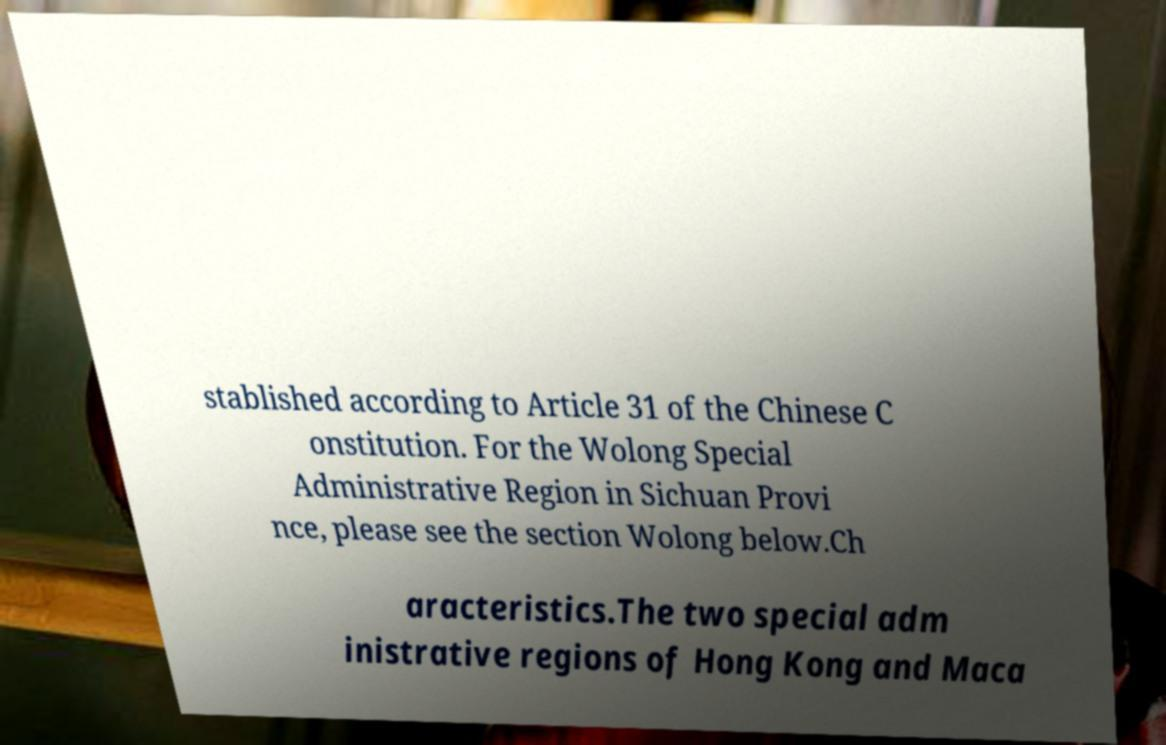Can you accurately transcribe the text from the provided image for me? stablished according to Article 31 of the Chinese C onstitution. For the Wolong Special Administrative Region in Sichuan Provi nce, please see the section Wolong below.Ch aracteristics.The two special adm inistrative regions of Hong Kong and Maca 